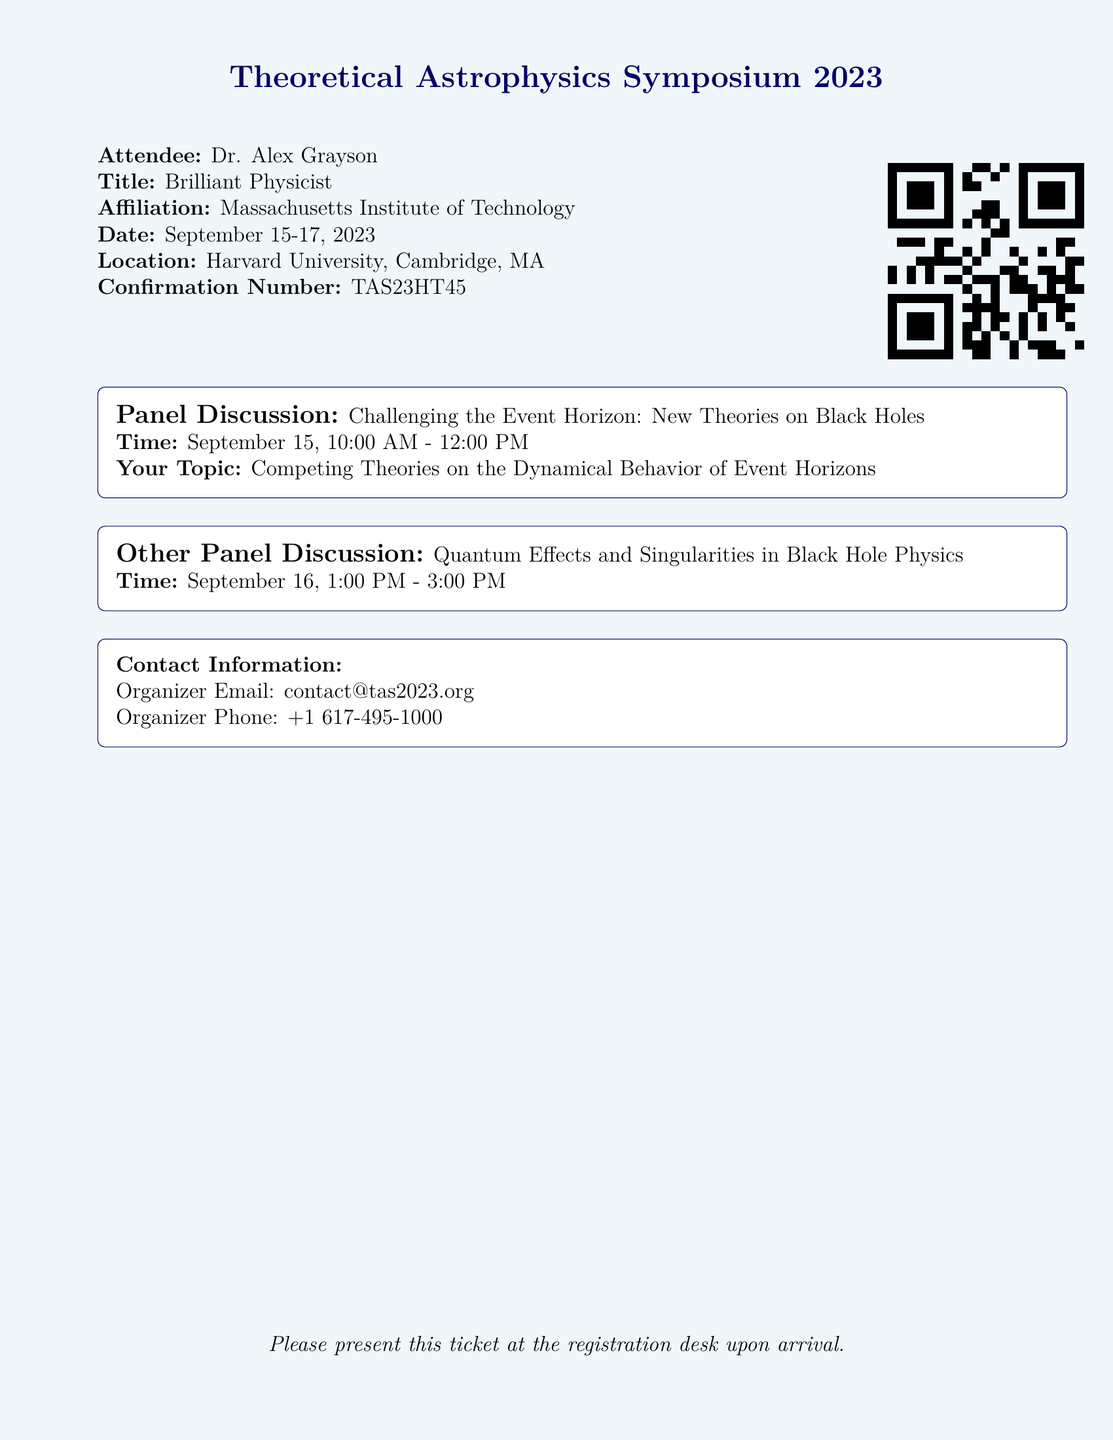What is the name of the symposium? The name of the symposium is prominently displayed at the top of the document.
Answer: Theoretical Astrophysics Symposium 2023 Who is the attendee listed on the ticket? The attendee's name is shown below the title.
Answer: Dr. Alex Grayson What is the location of the event? The location is specified in the details section of the ticket.
Answer: Harvard University, Cambridge, MA What is the confirmation number? The confirmation number is provided in the ticket details.
Answer: TAS23HT45 What topic will be discussed during the panel on September 15? The panel discussion topic is mentioned under the respective panel section.
Answer: Competing Theories on the Dynamical Behavior of Event Horizons What time does the Quantum Effects panel start? The starting time is listed in the panel discussion section.
Answer: 1:00 PM How can I contact the event organizer? Contact details for the organizer are included at the bottom of the ticket.
Answer: contact@tas2023.org What is the date range of the symposium? The date range is specified in the ticket details section.
Answer: September 15-17, 2023 What is the title of the panel that challenges traditional views? The title is explicitly mentioned in the panel discussion section.
Answer: Challenging the Event Horizon: New Theories on Black Holes 